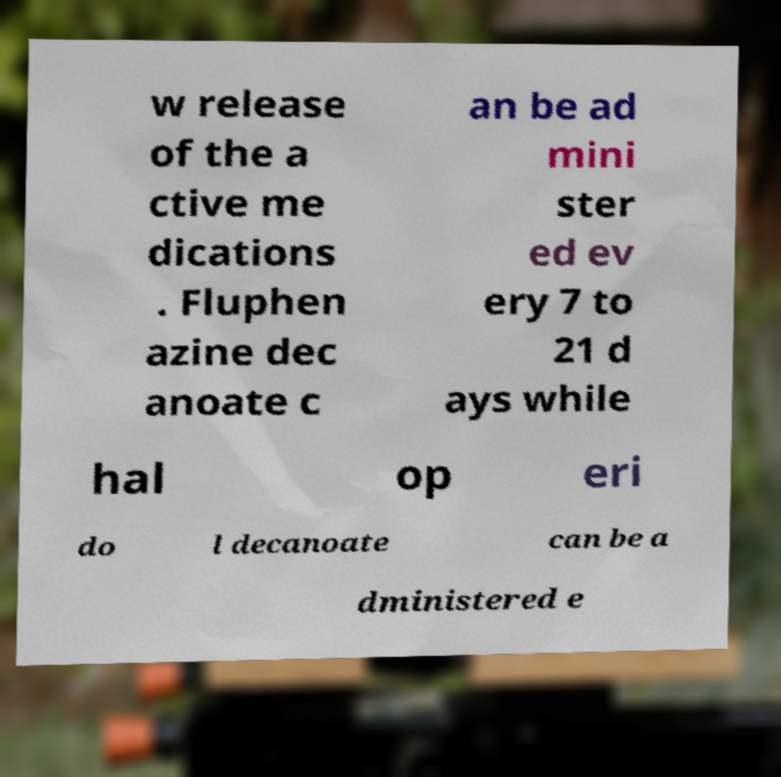Can you accurately transcribe the text from the provided image for me? w release of the a ctive me dications . Fluphen azine dec anoate c an be ad mini ster ed ev ery 7 to 21 d ays while hal op eri do l decanoate can be a dministered e 